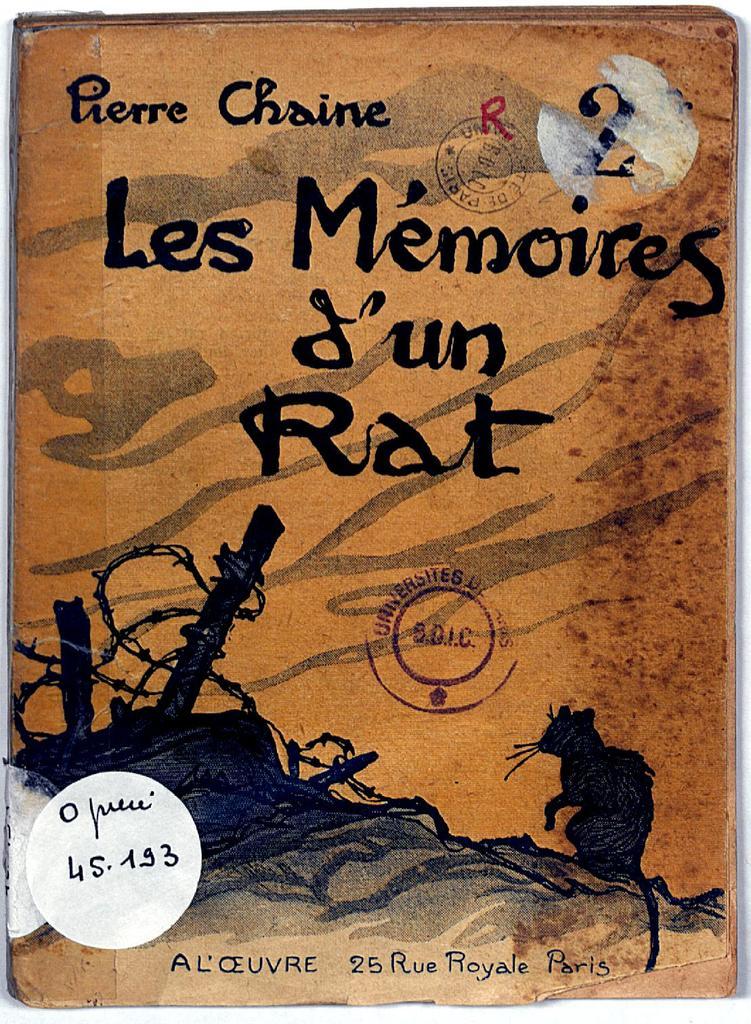What is the title of the book?
Keep it short and to the point. Les memoires d'un rat. Who is the author of the book?
Ensure brevity in your answer.  Pierre chaine. 